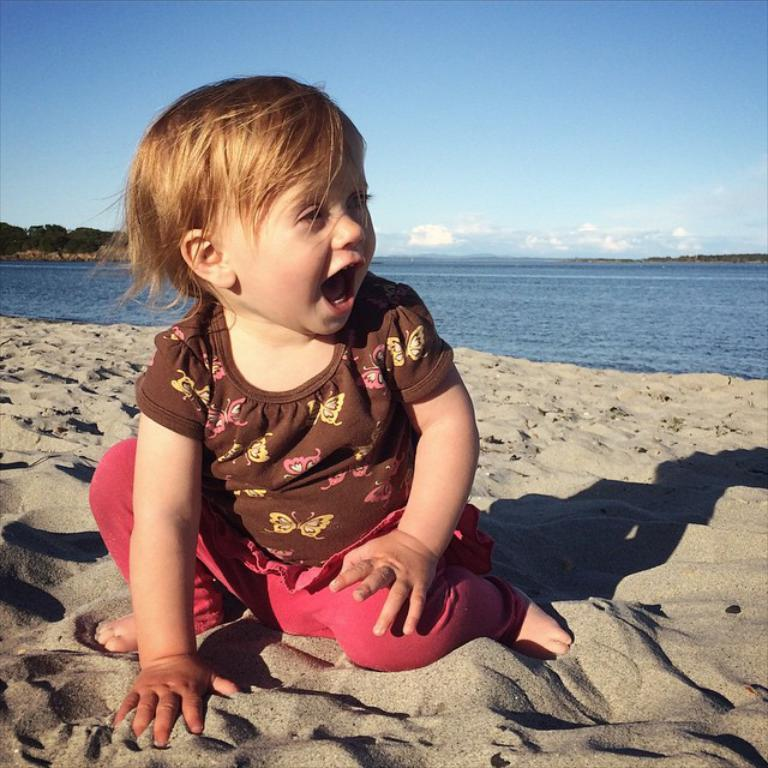What is the girl in the image sitting on? The girl is sitting on the sand. What can be seen in the background of the image? The background of the image includes the sea and mountains. What is visible in the sky in the image? The sky is visible in the background of the image. What type of punishment is being administered to the girl in the image? There is no indication of punishment in the image; the girl is simply sitting on the sand. 